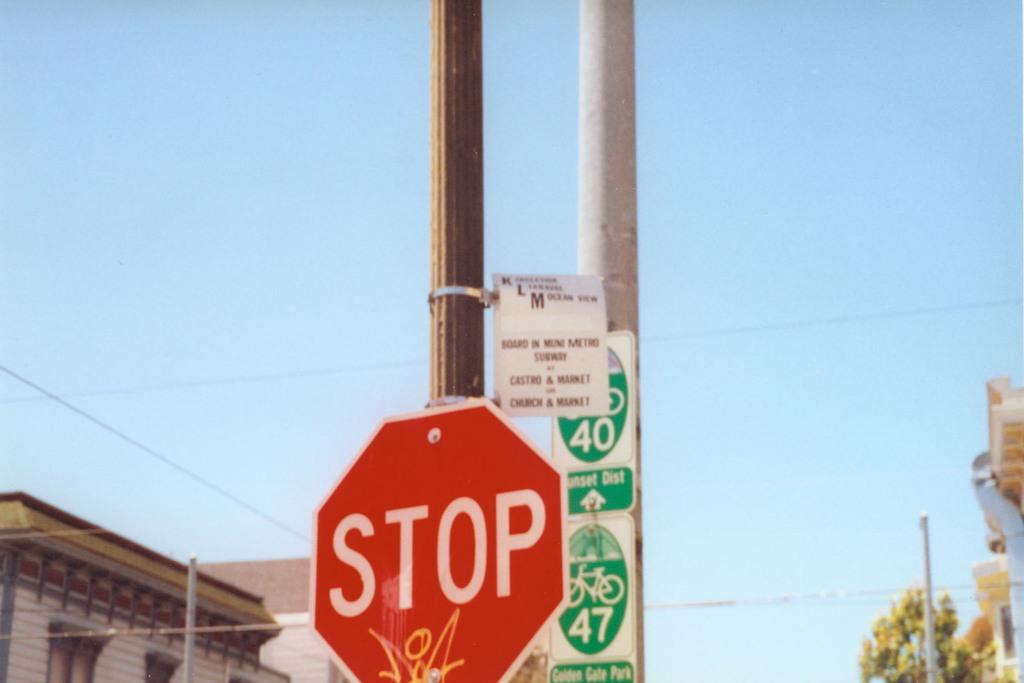<image>
Render a clear and concise summary of the photo. A Stop sign sits in front of a 40 and 47 sign with Bicycles on them. 